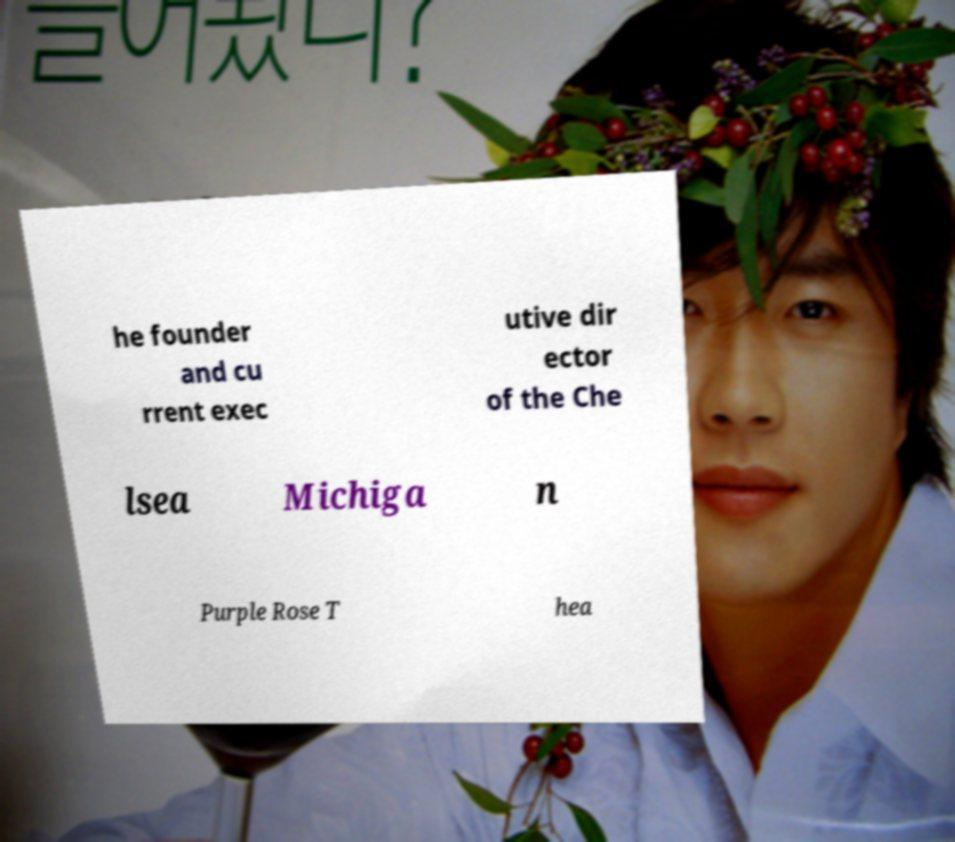What messages or text are displayed in this image? I need them in a readable, typed format. he founder and cu rrent exec utive dir ector of the Che lsea Michiga n Purple Rose T hea 